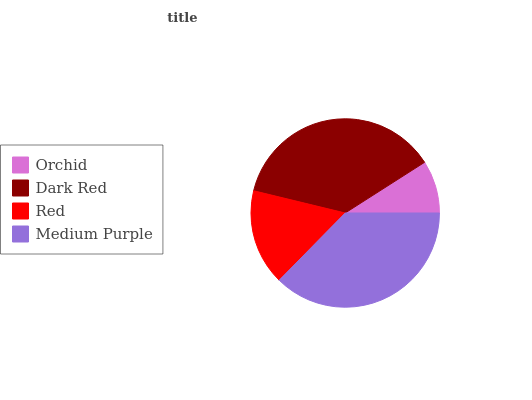Is Orchid the minimum?
Answer yes or no. Yes. Is Medium Purple the maximum?
Answer yes or no. Yes. Is Dark Red the minimum?
Answer yes or no. No. Is Dark Red the maximum?
Answer yes or no. No. Is Dark Red greater than Orchid?
Answer yes or no. Yes. Is Orchid less than Dark Red?
Answer yes or no. Yes. Is Orchid greater than Dark Red?
Answer yes or no. No. Is Dark Red less than Orchid?
Answer yes or no. No. Is Dark Red the high median?
Answer yes or no. Yes. Is Red the low median?
Answer yes or no. Yes. Is Medium Purple the high median?
Answer yes or no. No. Is Medium Purple the low median?
Answer yes or no. No. 